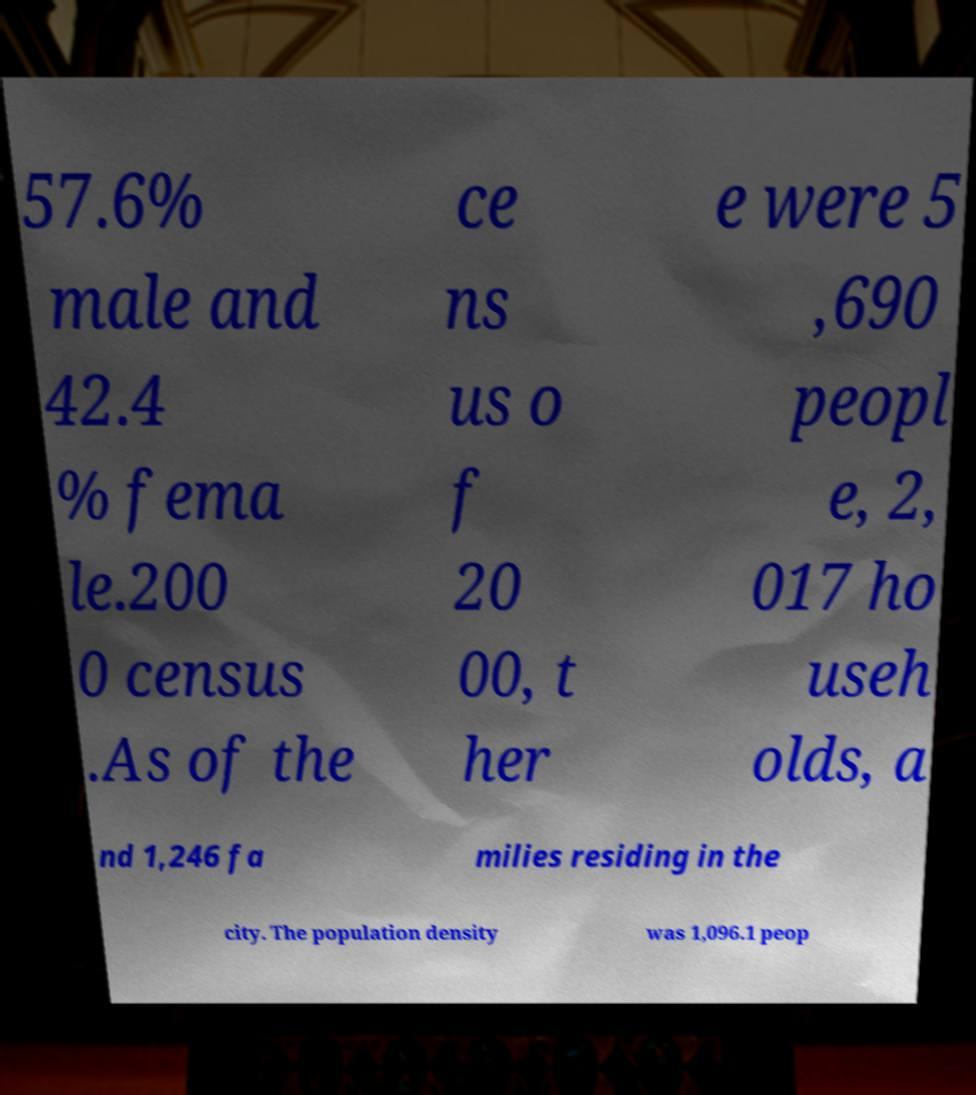Please read and relay the text visible in this image. What does it say? 57.6% male and 42.4 % fema le.200 0 census .As of the ce ns us o f 20 00, t her e were 5 ,690 peopl e, 2, 017 ho useh olds, a nd 1,246 fa milies residing in the city. The population density was 1,096.1 peop 